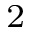Convert formula to latex. <formula><loc_0><loc_0><loc_500><loc_500>^ { 2 }</formula> 